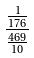Convert formula to latex. <formula><loc_0><loc_0><loc_500><loc_500>\frac { \frac { 1 } { 1 7 6 } } { \frac { 4 6 9 } { 1 0 } }</formula> 